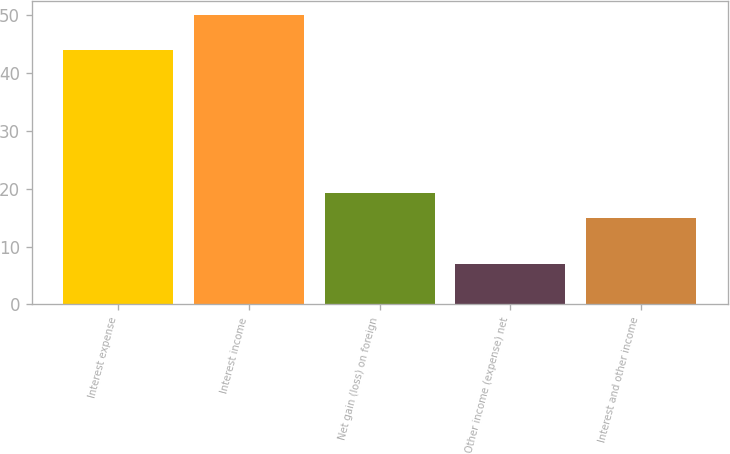Convert chart to OTSL. <chart><loc_0><loc_0><loc_500><loc_500><bar_chart><fcel>Interest expense<fcel>Interest income<fcel>Net gain (loss) on foreign<fcel>Other income (expense) net<fcel>Interest and other income<nl><fcel>44<fcel>50<fcel>19.3<fcel>7<fcel>15<nl></chart> 